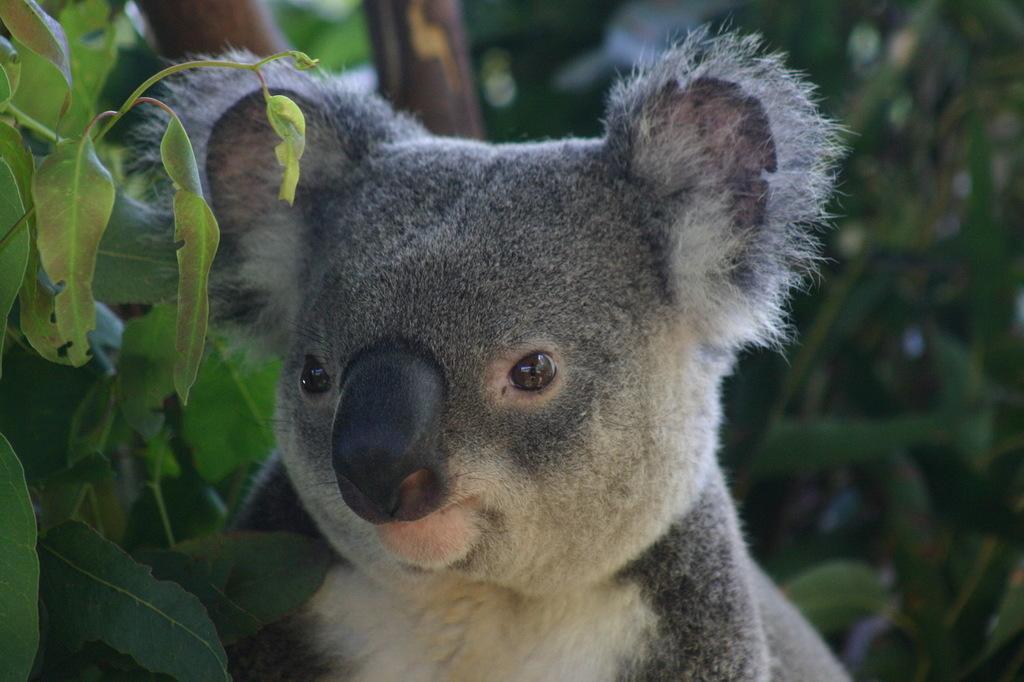Describe this image in one or two sentences. In the center of the image there is a animal. In the background of the image there are trees. 